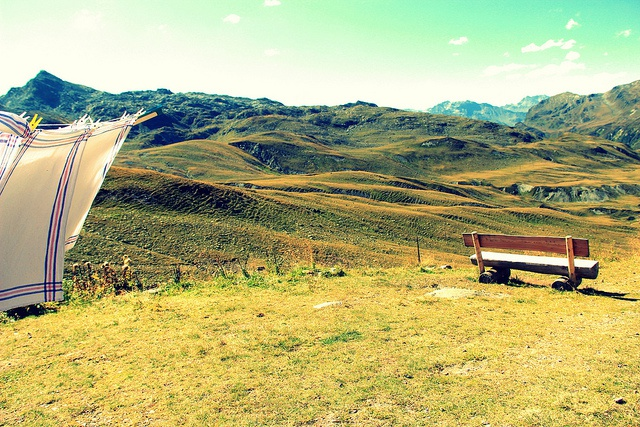Describe the objects in this image and their specific colors. I can see a bench in lightyellow, black, maroon, ivory, and brown tones in this image. 